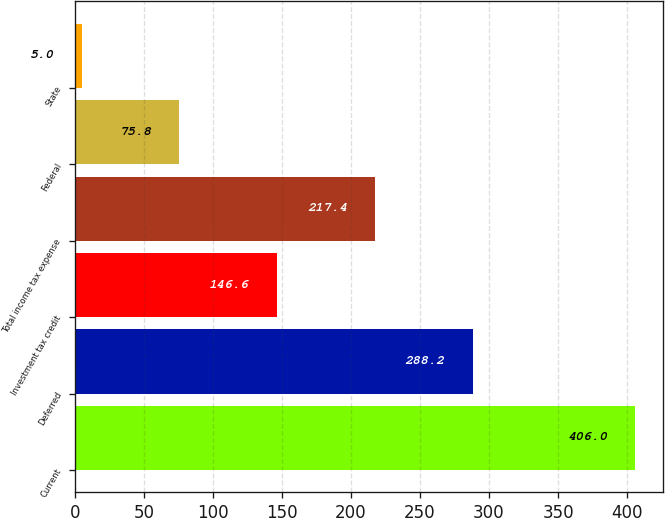<chart> <loc_0><loc_0><loc_500><loc_500><bar_chart><fcel>Current<fcel>Deferred<fcel>Investment tax credit<fcel>Total income tax expense<fcel>Federal<fcel>State<nl><fcel>406<fcel>288.2<fcel>146.6<fcel>217.4<fcel>75.8<fcel>5<nl></chart> 